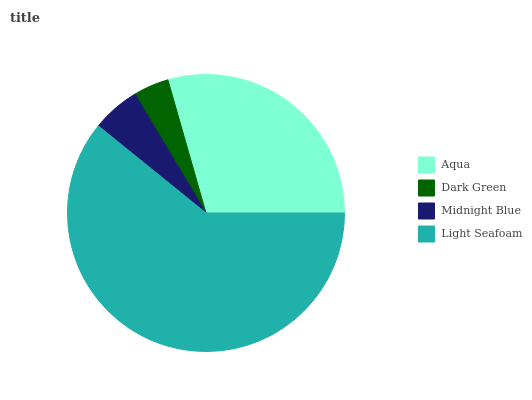Is Dark Green the minimum?
Answer yes or no. Yes. Is Light Seafoam the maximum?
Answer yes or no. Yes. Is Midnight Blue the minimum?
Answer yes or no. No. Is Midnight Blue the maximum?
Answer yes or no. No. Is Midnight Blue greater than Dark Green?
Answer yes or no. Yes. Is Dark Green less than Midnight Blue?
Answer yes or no. Yes. Is Dark Green greater than Midnight Blue?
Answer yes or no. No. Is Midnight Blue less than Dark Green?
Answer yes or no. No. Is Aqua the high median?
Answer yes or no. Yes. Is Midnight Blue the low median?
Answer yes or no. Yes. Is Light Seafoam the high median?
Answer yes or no. No. Is Aqua the low median?
Answer yes or no. No. 